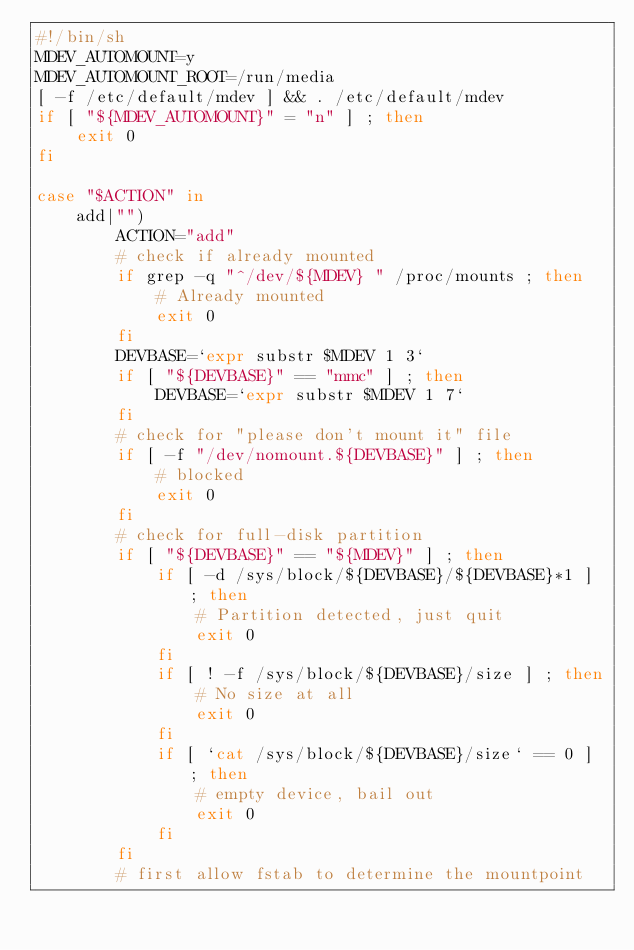<code> <loc_0><loc_0><loc_500><loc_500><_Bash_>#!/bin/sh
MDEV_AUTOMOUNT=y
MDEV_AUTOMOUNT_ROOT=/run/media
[ -f /etc/default/mdev ] && . /etc/default/mdev
if [ "${MDEV_AUTOMOUNT}" = "n" ] ; then
	exit 0
fi

case "$ACTION" in
	add|"")
		ACTION="add"
		# check if already mounted
		if grep -q "^/dev/${MDEV} " /proc/mounts ; then
			# Already mounted
			exit 0
		fi
		DEVBASE=`expr substr $MDEV 1 3`
		if [ "${DEVBASE}" == "mmc" ] ; then
			DEVBASE=`expr substr $MDEV 1 7`
		fi
		# check for "please don't mount it" file
		if [ -f "/dev/nomount.${DEVBASE}" ] ; then
			# blocked
			exit 0
		fi
		# check for full-disk partition
		if [ "${DEVBASE}" == "${MDEV}" ] ; then
			if [ -d /sys/block/${DEVBASE}/${DEVBASE}*1 ] ; then
				# Partition detected, just quit
				exit 0
			fi
			if [ ! -f /sys/block/${DEVBASE}/size ] ; then
				# No size at all
				exit 0
			fi
			if [ `cat /sys/block/${DEVBASE}/size` == 0 ] ; then
				# empty device, bail out
				exit 0
			fi
		fi
		# first allow fstab to determine the mountpoint</code> 